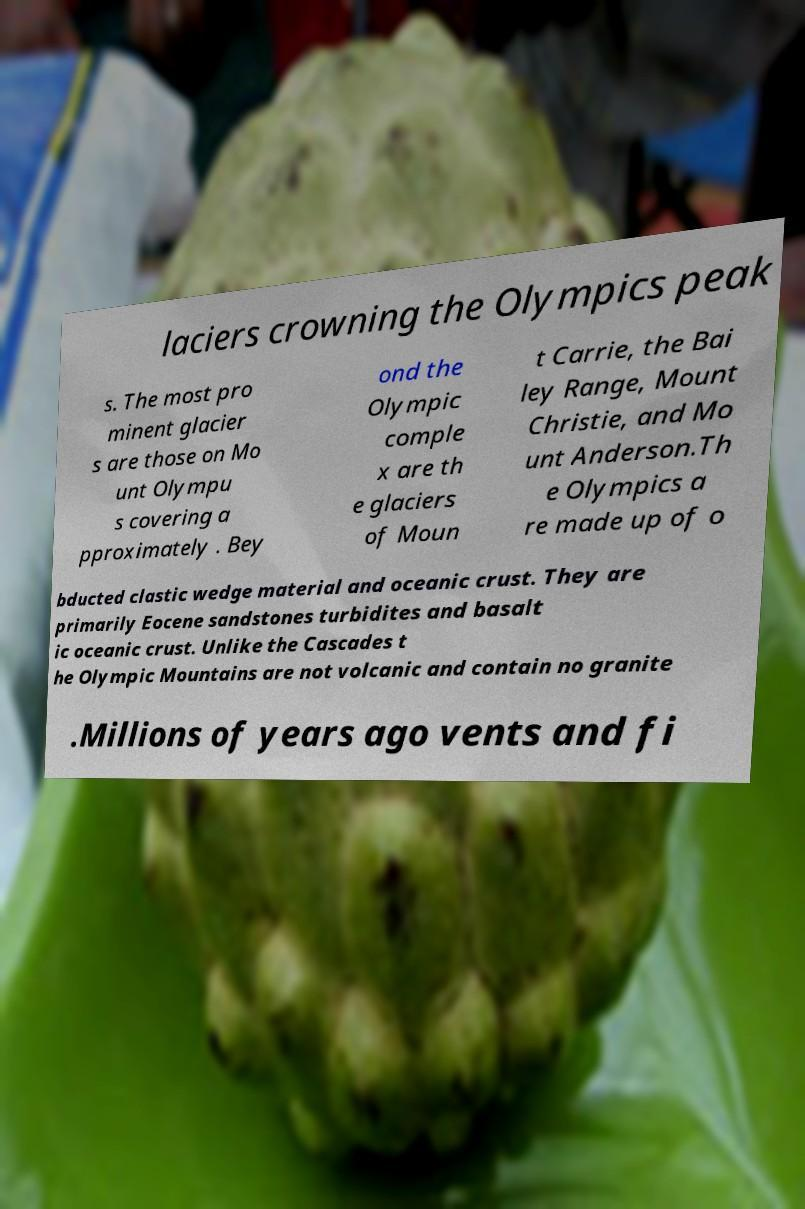There's text embedded in this image that I need extracted. Can you transcribe it verbatim? laciers crowning the Olympics peak s. The most pro minent glacier s are those on Mo unt Olympu s covering a pproximately . Bey ond the Olympic comple x are th e glaciers of Moun t Carrie, the Bai ley Range, Mount Christie, and Mo unt Anderson.Th e Olympics a re made up of o bducted clastic wedge material and oceanic crust. They are primarily Eocene sandstones turbidites and basalt ic oceanic crust. Unlike the Cascades t he Olympic Mountains are not volcanic and contain no granite .Millions of years ago vents and fi 